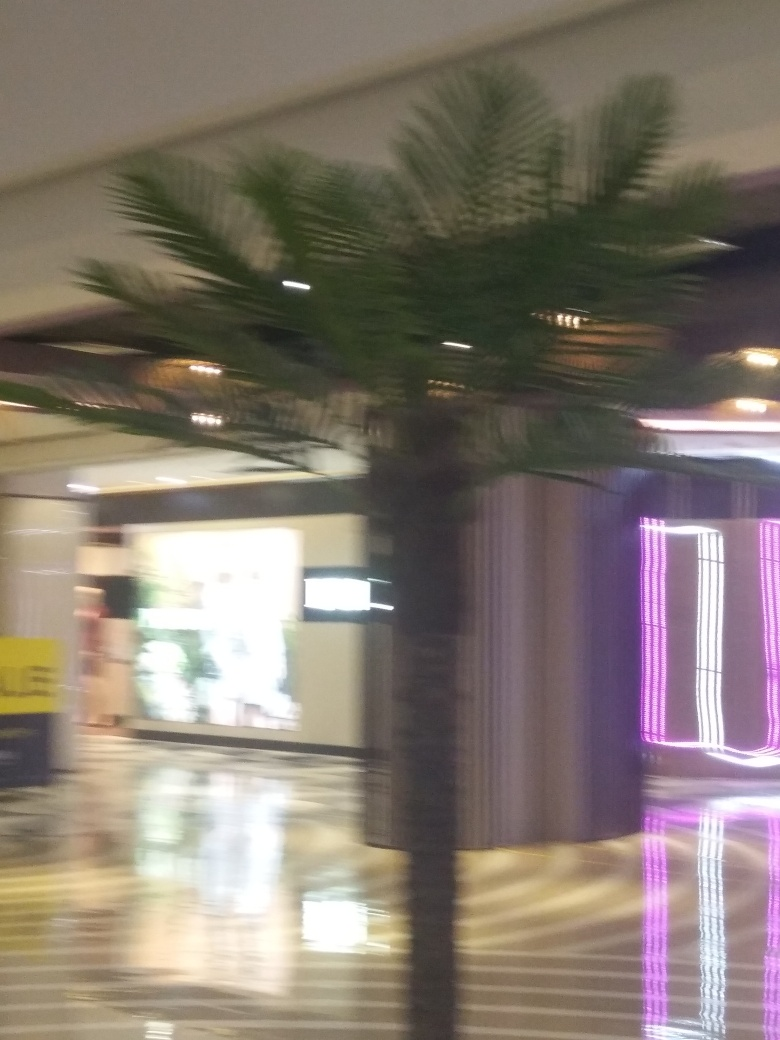Describe the environment where this image was taken. The image was taken indoors, possibly inside a mall or a commercial building. The presence of the palm tree points to an interior landscaping design meant to add a touch of nature and greenery. We can also observe artificial lighting, including neon accents, which suggests a modern and possibly trendy setting. What can the lighting tell us about the place? The use of neon lighting and the indoor palm tree might indicate that the place is designed to be visually appealing and vibrant, perhaps aiming to create a distinct atmosphere. Such lighting could imply that the venue values aesthetic experience, possibly catering to a younger crowd or looking to create an inviting ambiance. 